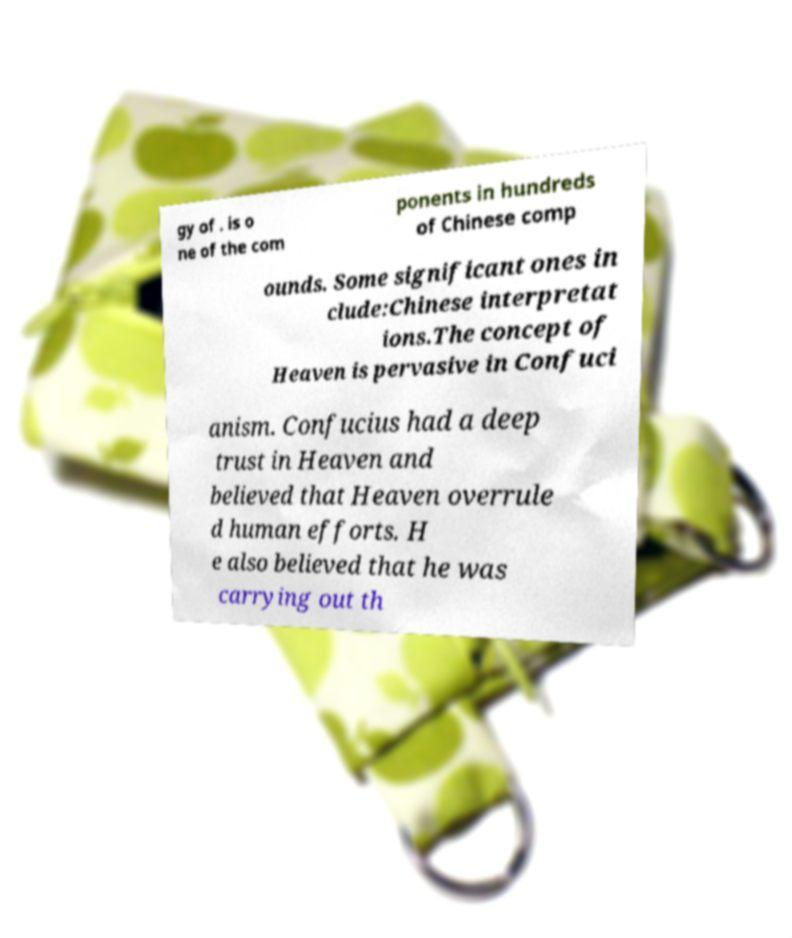For documentation purposes, I need the text within this image transcribed. Could you provide that? gy of . is o ne of the com ponents in hundreds of Chinese comp ounds. Some significant ones in clude:Chinese interpretat ions.The concept of Heaven is pervasive in Confuci anism. Confucius had a deep trust in Heaven and believed that Heaven overrule d human efforts. H e also believed that he was carrying out th 